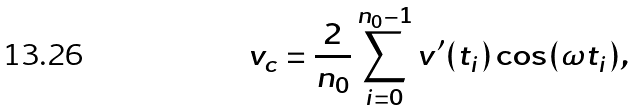<formula> <loc_0><loc_0><loc_500><loc_500>v _ { c } = \frac { 2 } { n _ { 0 } } \sum _ { i = 0 } ^ { n _ { 0 } - 1 } v ^ { \prime } ( t _ { i } ) \cos ( \omega t _ { i } ) ,</formula> 